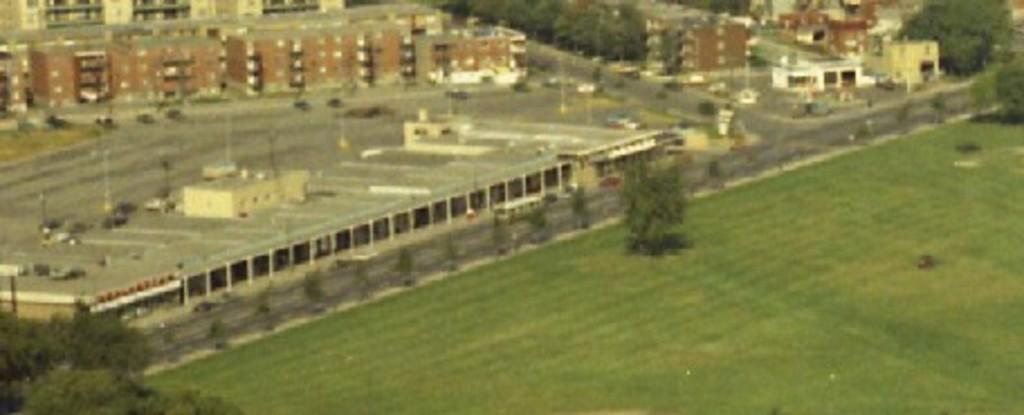What type of structures can be seen in the image? There are buildings in the image. What is the purpose of the road in the image? The road in the image is used for vehicles to travel on. What types of vehicles are visible in the image? There are vehicles in the image. What type of vegetation can be seen in the image? There are trees and grass in the image. Can you see a zephyr blowing through the trees in the image? There is no mention of a zephyr in the image, and it is not visible. What color is the spot on the grass in the image? There is no spot mentioned or visible on the grass in the image. 